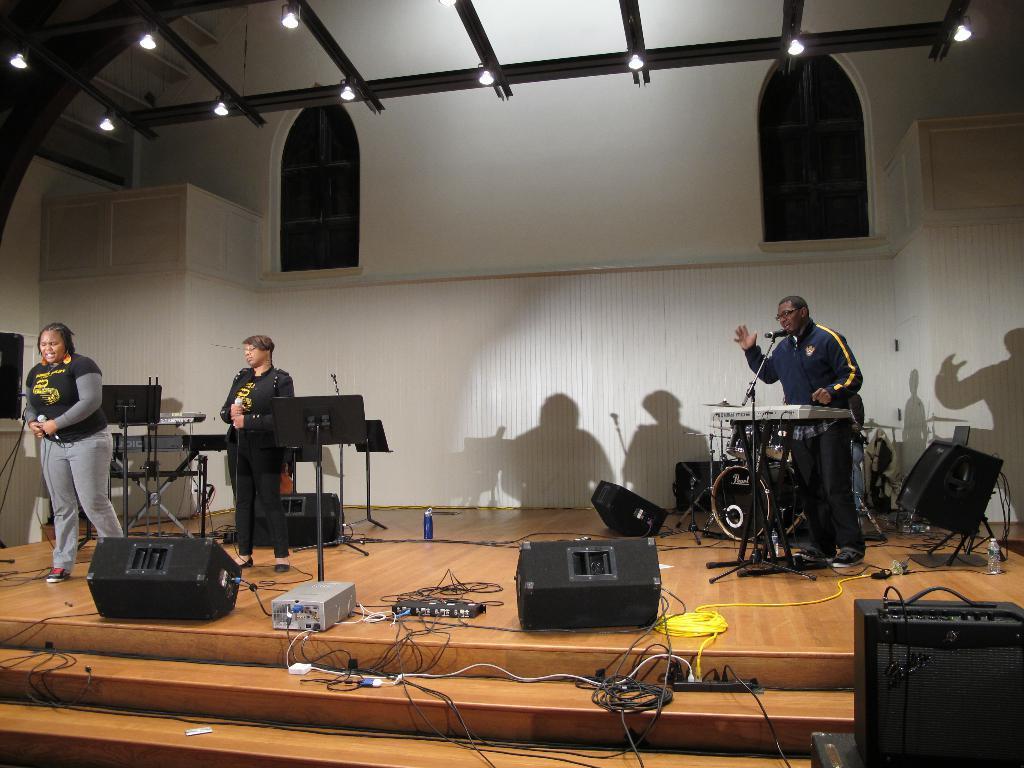Could you give a brief overview of what you see in this image? In this image three persons are standing on the stage having few objects on it. Right side a person is standing behind the piano. Before the piano there is a mike stand. Left side two persons are standing on the stage. They are holding mics in their hands. Behind them there are few strands having boards. Top of the image there are few lights attached to the roof. Bottom of the image there are stairs. Background there is a wall having windows. 